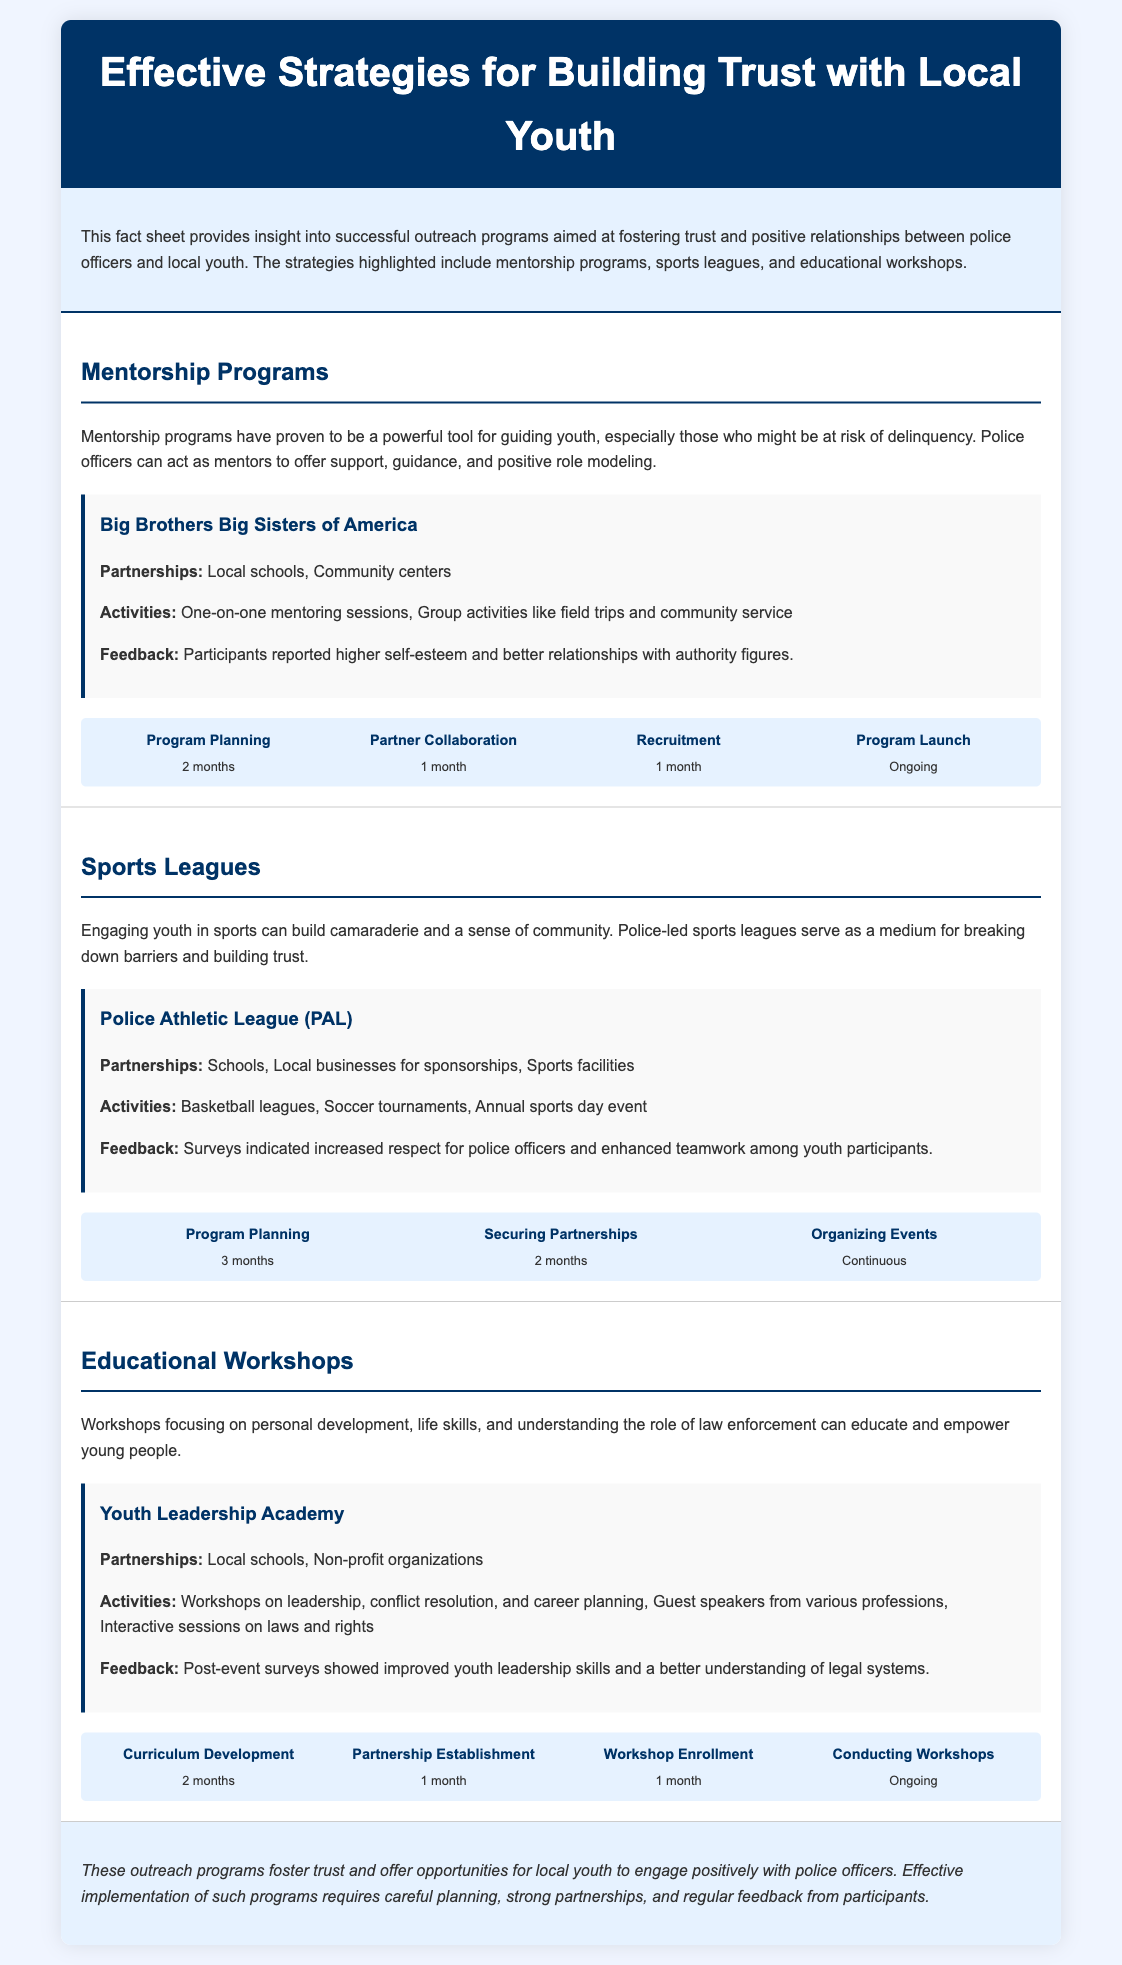What are the main types of outreach programs? The document lists mentorship programs, sports leagues, and educational workshops as the main types of outreach programs.
Answer: Mentorship programs, sports leagues, educational workshops What is the duration for program planning in mentorship programs? The document states that the program planning for mentorship programs takes 2 months.
Answer: 2 months Who is the primary partner in the Youth Leadership Academy? The document mentions that local schools and non-profit organizations are the primary partners for the Youth Leadership Academy.
Answer: Local schools, Non-profit organizations What activity is included in the Police Athletic League? The document states that basketball leagues are one of the activities included in the Police Athletic League.
Answer: Basketball leagues What is the feedback from participants in mentorship programs? The document indicates that participants in mentorship programs reported higher self-esteem and better relationships with authority figures.
Answer: Higher self-esteem and better relationships with authority figures How long does it take to develop the curriculum for workshops? According to the document, curriculum development for workshops takes 2 months.
Answer: 2 months What type of feedback is collected from participants? The document mentions that feedback is collected through surveys before and after events to assess their impact and effectiveness.
Answer: Surveys What is the first step in the timeline for sports leagues? The document lists program planning as the first step in the timeline for sports leagues, taking 3 months.
Answer: Program Planning What is the goal of engaging youth in sports? The document explains that the goal of engaging youth in sports is to build camaraderie and a sense of community.
Answer: Build camaraderie and a sense of community 